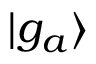<formula> <loc_0><loc_0><loc_500><loc_500>\ m a t h i n n e r { | { g _ { a } } \rangle }</formula> 